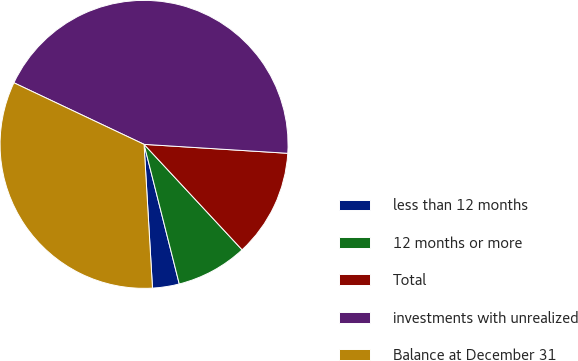Convert chart. <chart><loc_0><loc_0><loc_500><loc_500><pie_chart><fcel>less than 12 months<fcel>12 months or more<fcel>Total<fcel>investments with unrealized<fcel>Balance at December 31<nl><fcel>3.0%<fcel>7.99%<fcel>12.09%<fcel>43.96%<fcel>32.97%<nl></chart> 